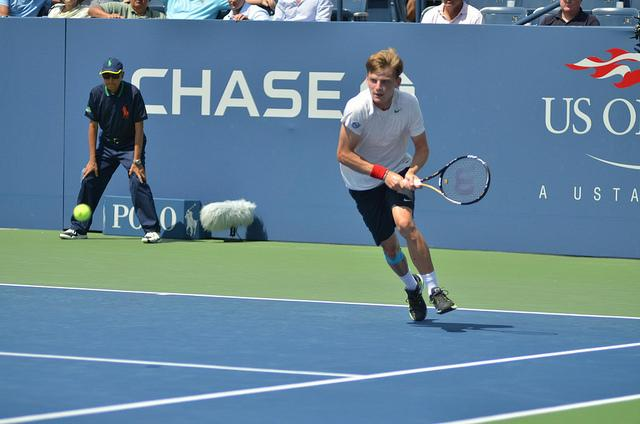What is he doing?

Choices:
A) cleaning up
B) chasing ball
C) falling
D) dropping racquet chasing ball 